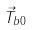Convert formula to latex. <formula><loc_0><loc_0><loc_500><loc_500>\vec { T } _ { b 0 }</formula> 